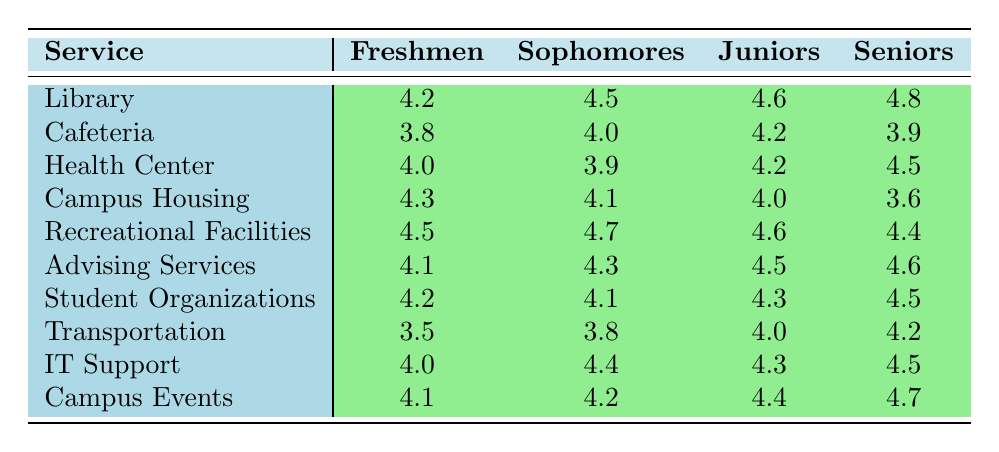What is the highest satisfaction rating for the Library? The highest satisfaction rating for the Library is 4.8, which is given by the Seniors.
Answer: 4.8 Which service received the lowest satisfaction rating from Freshmen? The service that received the lowest satisfaction rating from Freshmen is Transportation, with a rating of 3.5.
Answer: 3.5 What is the average satisfaction rating for Sophomores across all services? The sum of satisfaction ratings for Sophomores is (4.5 + 4.0 + 3.9 + 4.1 + 4.7 + 4.3 + 4.1 + 3.8 + 4.4 + 4.2) = 43.1, and there are 10 services, so the average is 43.1 / 10 = 4.31.
Answer: 4.31 Do Seniors rate Campus Housing higher than the Health Center? Yes, Seniors rate Campus Housing with a score of 3.6, which is lower than their rating of the Health Center at 4.5.
Answer: Yes What is the difference in satisfaction ratings between Juniors and Seniors for the Cafeteria? The rating from Juniors for the Cafeteria is 4.2, and for Seniors, it is 3.9. The difference is 4.2 - 3.9 = 0.3.
Answer: 0.3 Which service has the highest satisfaction rating from Juniors? The service with the highest satisfaction rating from Juniors is the Library, which received a rating of 4.6.
Answer: 4.6 What is the overall trend of satisfaction ratings for Recreational Facilities from Freshmen to Seniors? The ratings for Recreational Facilities are 4.5 (Freshmen), 4.7 (Sophomores), 4.6 (Juniors), and 4.4 (Seniors). The trend shows a peak at Sophomores, then a slight decline for Juniors and Seniors.
Answer: Peak at Sophomores, then decline How many services have an average rating of over 4.0 from Freshmen? The services rated over 4.0 from Freshmen are Library (4.2), Health Center (4.0), Campus Housing (4.3), Recreational Facilities (4.5), Advising Services (4.1), Student Organizations (4.2), IT Support (4.0), and Campus Events (4.1). That totals 8 services.
Answer: 8 Which group rates the Advising Services the highest? Seniors rate the Advising Services the highest with a score of 4.6, higher than Freshmen (4.1), Sophomores (4.3), and Juniors (4.5).
Answer: Seniors Is there any service rated the same by all groups? No, there are no services that received the same rating from all groups.
Answer: No 